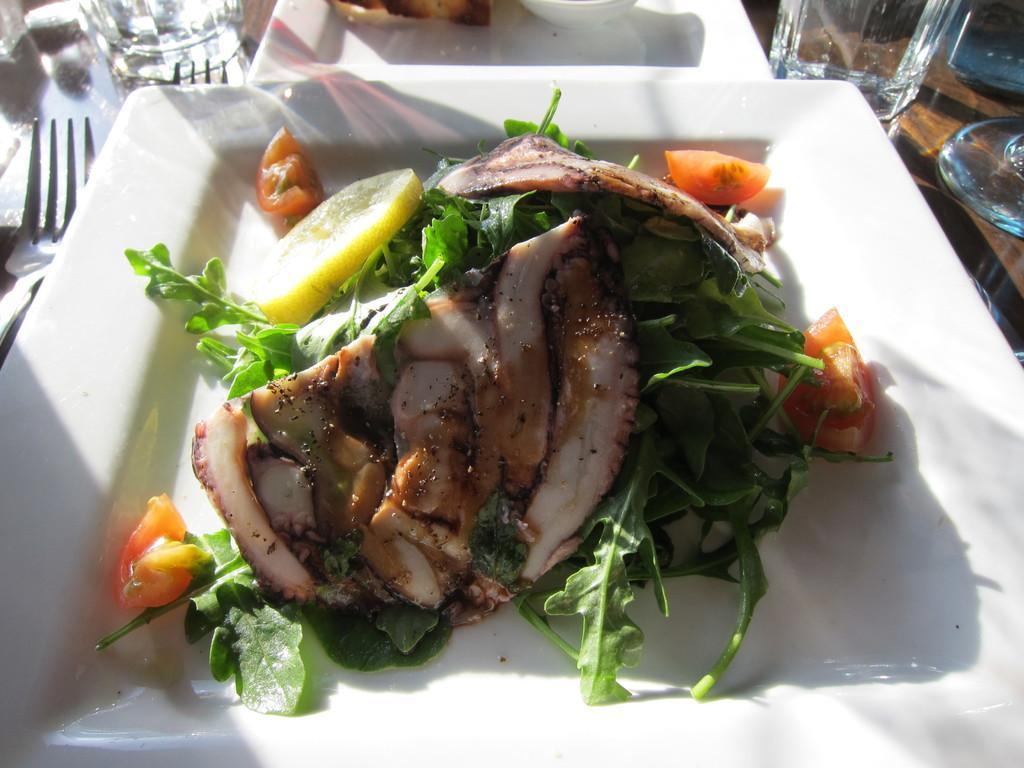In one or two sentences, can you explain what this image depicts? In the picture I can see food item in a white color plate. I can also see forks, glasses, a plate and some other things. 